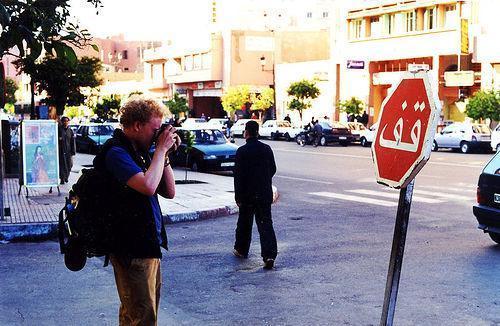How many people are in the picture?
Give a very brief answer. 2. How many people are pictured here?
Give a very brief answer. 2. How many red signs can be seen?
Give a very brief answer. 1. 